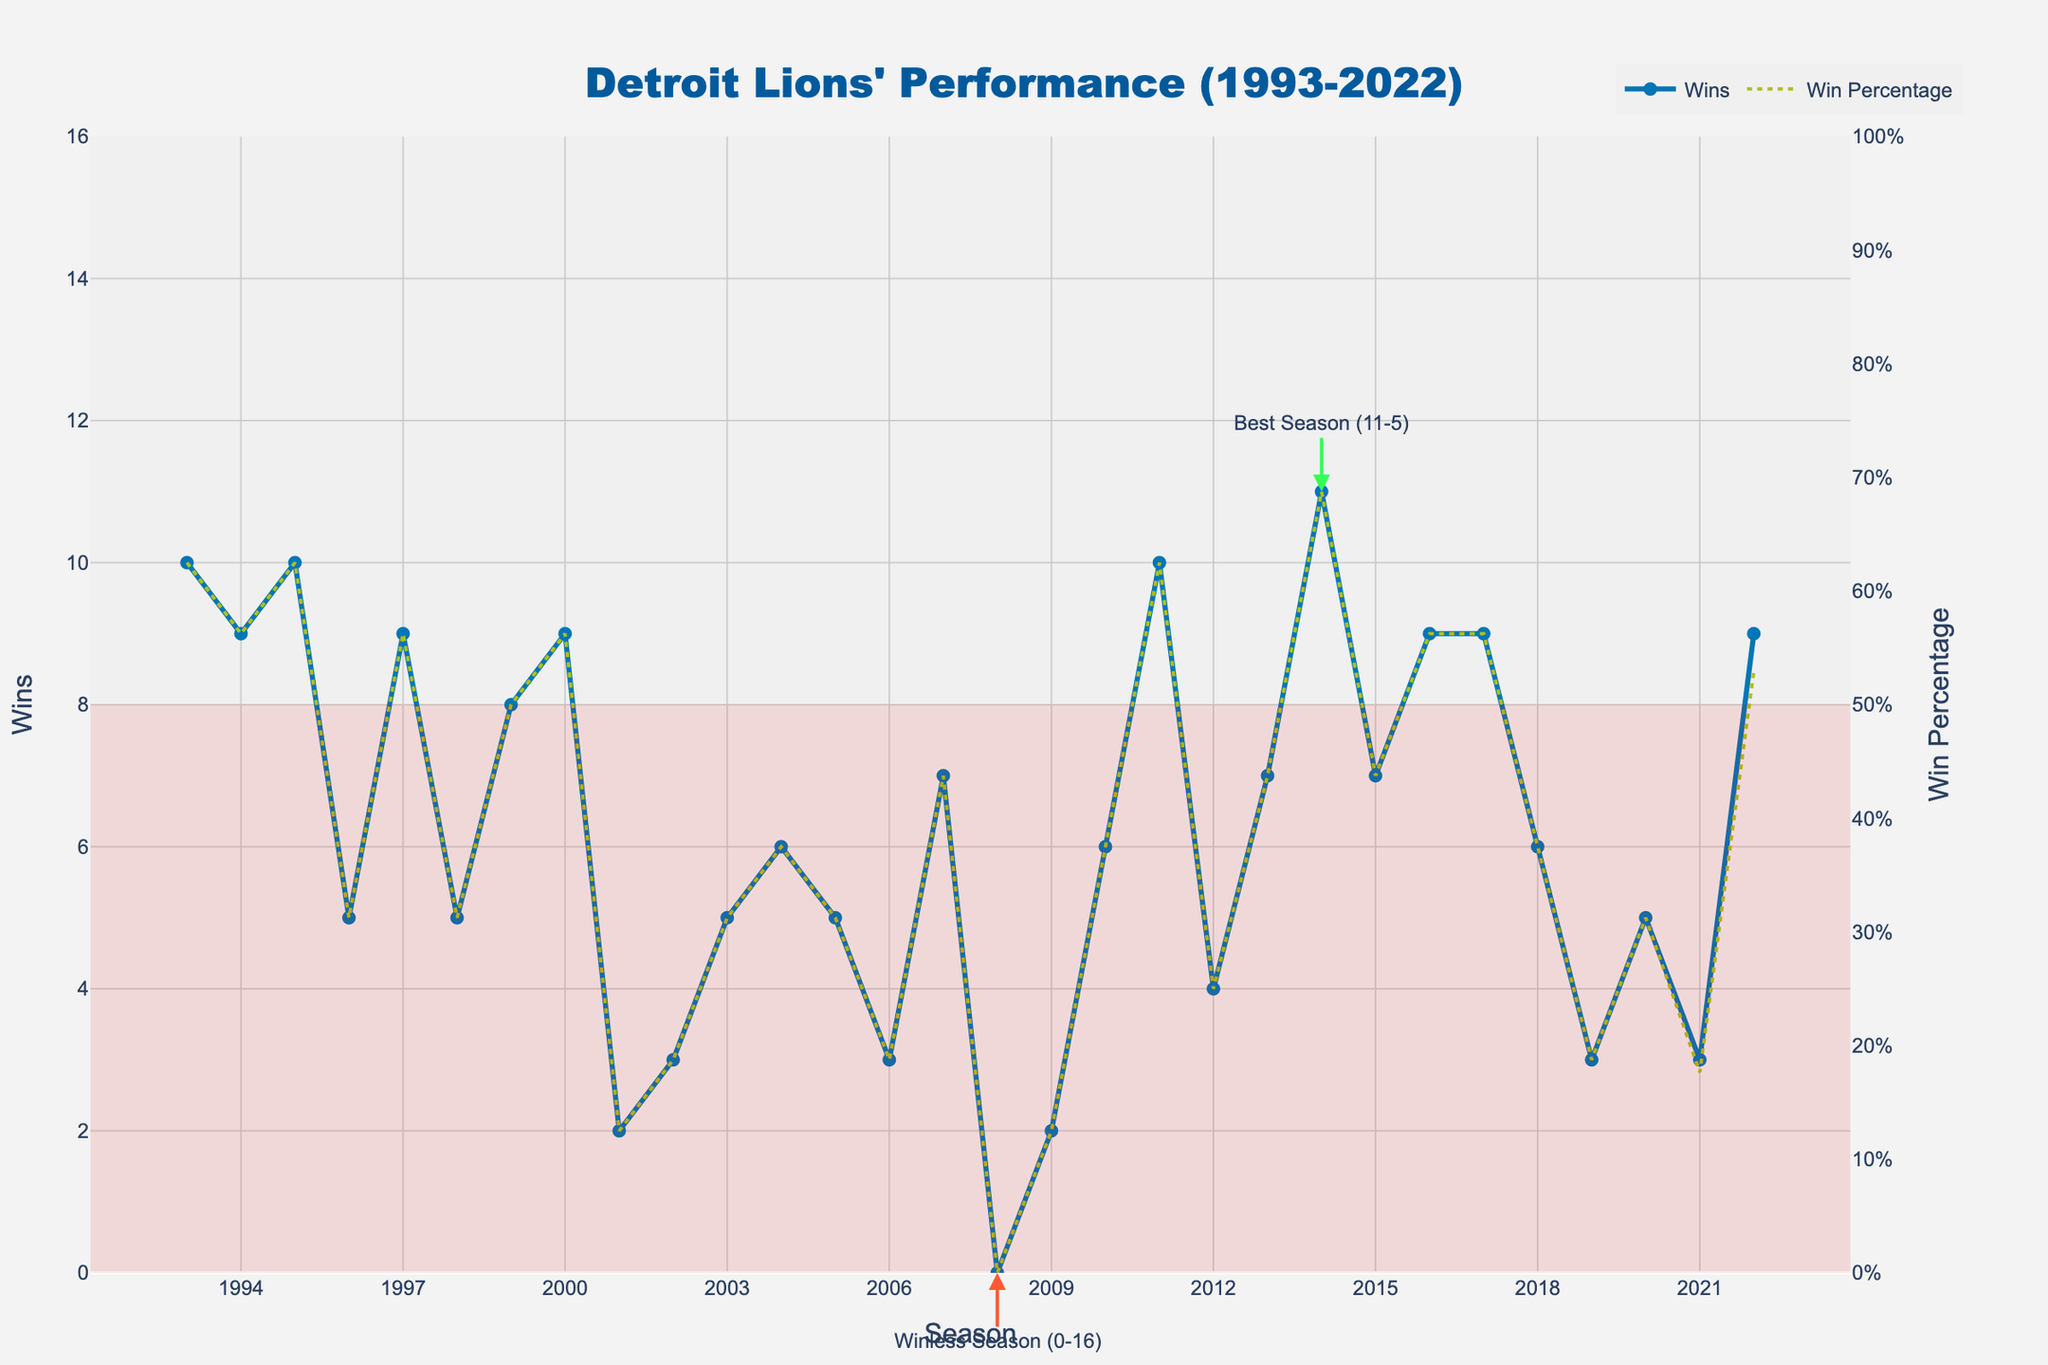What's the best season in terms of wins? The annotation on the plot indicates that the 2014 season was the best, with 11 wins.
Answer: 2014 Which season had the lowest number of wins? The annotation on the plot indicates that the 2008 season was winless with 0 wins.
Answer: 2008 How does the win percentage trend from 2019 to 2022? The win percentage in 2019 was relatively low and increased significantly by 2022. This upward trend is seen by the rising dotted yellow line in this interval.
Answer: Increasing Compare the win counts of the 1995 and 2007 seasons. Which one had more wins? In 1995, the chart shows 10 wins, whereas in 2007, it shows 7 wins. Thus, 1995 had more wins.
Answer: 1995 What's the win percentage for the worst season? The worst season is 2008 with 0 wins. Thus, the win percentage is 0%.
Answer: 0% Which range of seasons had consistently losing records based on the shaded area? The shaded area indicates losing seasons (fewer than 8 wins). The period from 2001 to 2010 mostly falls under this range, except 2007.
Answer: 2001-2010 What visual element indicates winless and the best seasons? The plot includes specific annotations with arrows: "Winless Season (0-16)" for 2008, and "Best Season (11-5)" for 2014.
Answer: Annotations with arrows Which season had the highest win percentage? The highest win percentage corresponds to the best season. The annotation indicates 2014 was the best season, thus it had the highest win percentage.
Answer: 2014 How many total wins did the team achieve from 2016 to 2018? Summing the wins for 2016, 2017, and 2018: 9 (2016) + 9 (2017) + 6 (2018) = 24 wins.
Answer: 24 Compare the number of wins in the 1993 and 2022 seasons. Who had more wins? The 1993 season had 10 wins, and the 2022 season had 9 wins, so 1993 had more wins.
Answer: 1993 